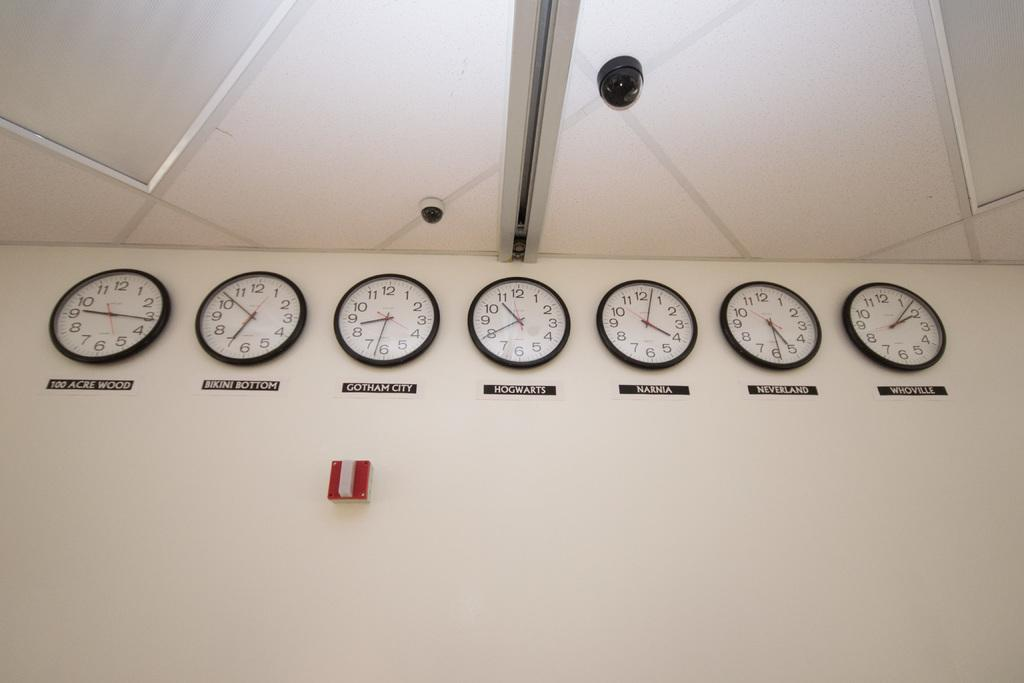<image>
Summarize the visual content of the image. A bank of clocks on the wall that show the time in fictional places like Bikini Bottom and 100 Acre Woods. 